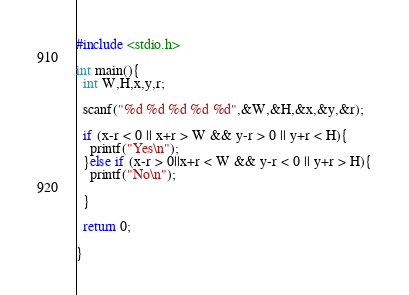<code> <loc_0><loc_0><loc_500><loc_500><_C_>#include <stdio.h>

int main(){
  int W,H,x,y,r;

  scanf("%d %d %d %d %d",&W,&H,&x,&y,&r);

  if (x-r < 0 || x+r > W && y-r > 0 || y+r < H){
    printf("Yes\n");
  }else if (x-r > 0||x+r < W && y-r < 0 || y+r > H){
    printf("No\n");

  }
 
  return 0;

}</code> 